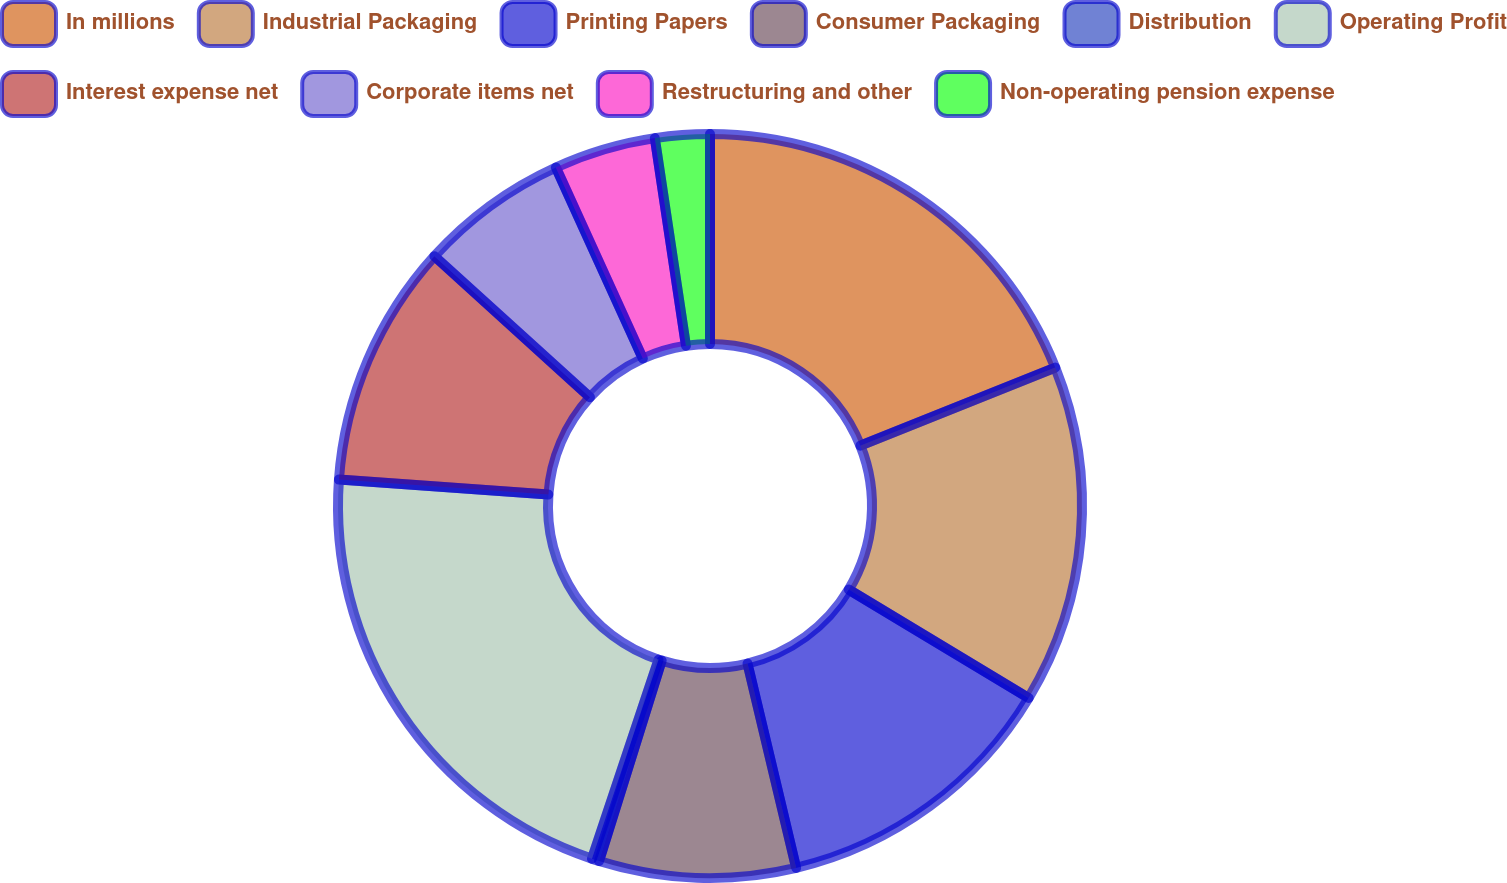Convert chart to OTSL. <chart><loc_0><loc_0><loc_500><loc_500><pie_chart><fcel>In millions<fcel>Industrial Packaging<fcel>Printing Papers<fcel>Consumer Packaging<fcel>Distribution<fcel>Operating Profit<fcel>Interest expense net<fcel>Corporate items net<fcel>Restructuring and other<fcel>Non-operating pension expense<nl><fcel>18.93%<fcel>14.7%<fcel>12.65%<fcel>8.54%<fcel>0.32%<fcel>20.99%<fcel>10.59%<fcel>6.48%<fcel>4.43%<fcel>2.37%<nl></chart> 